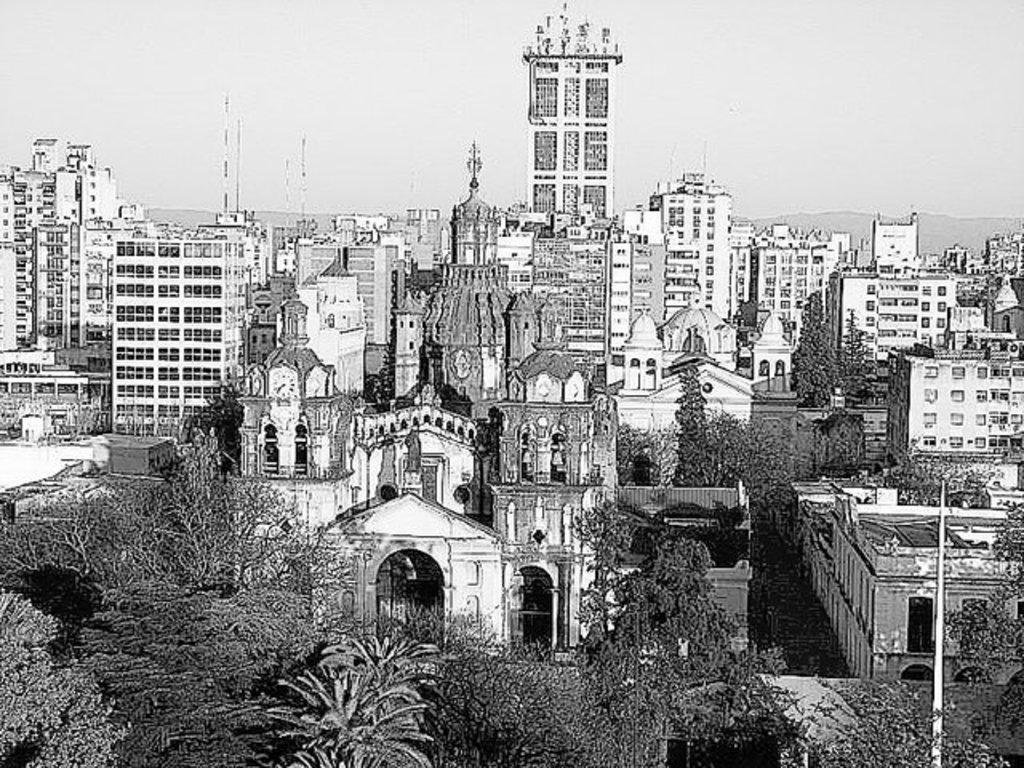What type of structures can be seen in the image? There are buildings in the image. What other natural elements are present in the image? There are trees in the image. What is visible in the background of the image? The sky is visible in the image. What type of pump can be seen operating in the image? There is no pump present in the image. What type of beast can be seen roaming in the image? There is no beast present in the image. 